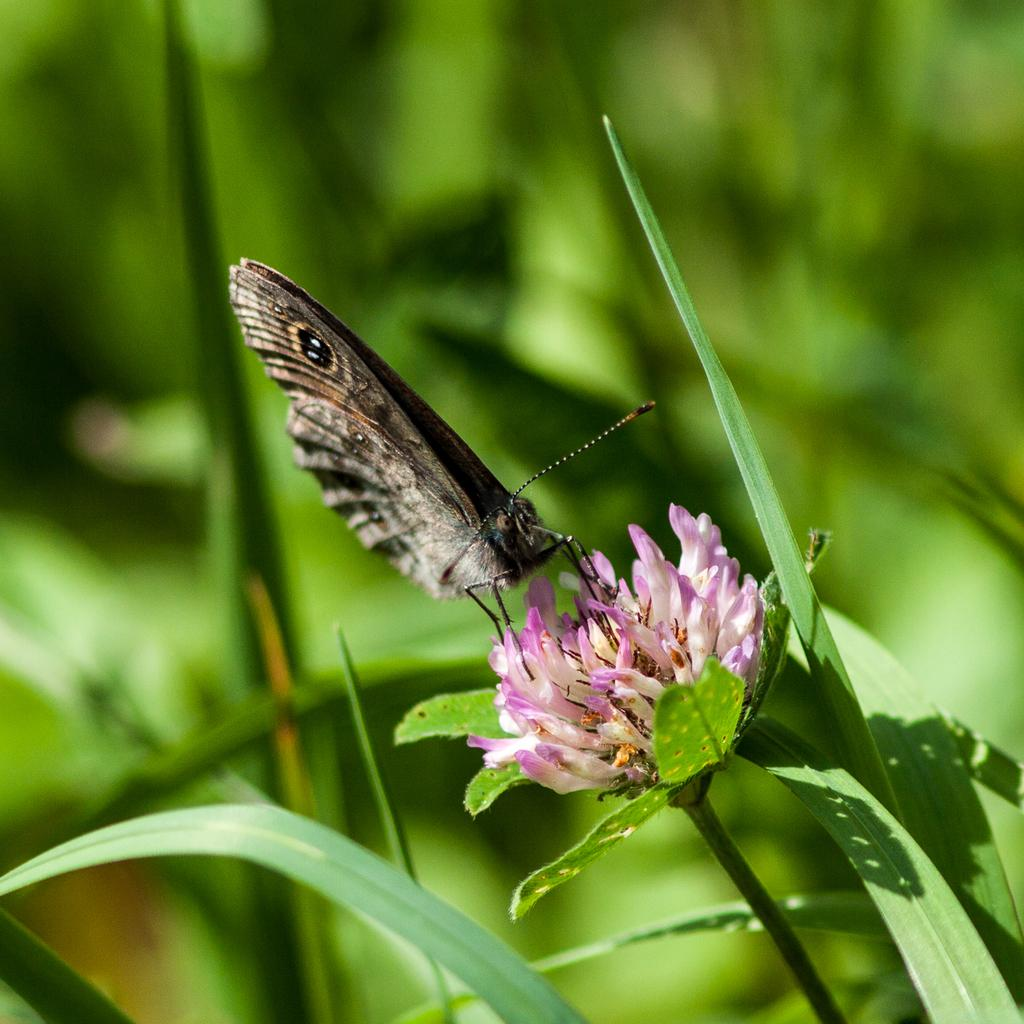What is the main subject of the image? There is a flower with a stem in the image. Are there any other living creatures present in the image? Yes, there is a butterfly on the flower. What else can be seen in the image besides the flower and butterfly? There are leaves in the image. What color is the background of the image? The background of the image is green. What is the condition of the roof in the image? There is no roof present in the image; it features a flower, butterfly, and leaves. Can you tell me how many fields are visible in the image? There are no fields visible in the image; it features a flower, butterfly, and leaves. 